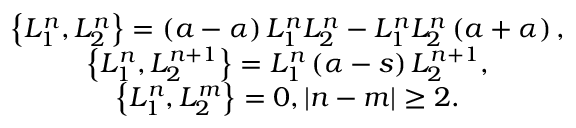<formula> <loc_0><loc_0><loc_500><loc_500>\begin{array} { c } { { \left \{ L _ { 1 } ^ { n } , L _ { 2 } ^ { n } \right \} = \left ( a - \alpha \right ) L _ { 1 } ^ { n } L _ { 2 } ^ { n } - L _ { 1 } ^ { n } L _ { 2 } ^ { n } \left ( a + \alpha \right ) , } } \\ { { \left \{ L _ { 1 } ^ { n } , L _ { 2 } ^ { n + 1 } \right \} = L _ { 1 } ^ { n } \left ( \alpha - s \right ) L _ { 2 } ^ { n + 1 } , } } \\ { { \left \{ L _ { 1 } ^ { n } , L _ { 2 } ^ { m } \right \} = 0 , \left | n - m \right | \geq 2 . } } \end{array}</formula> 